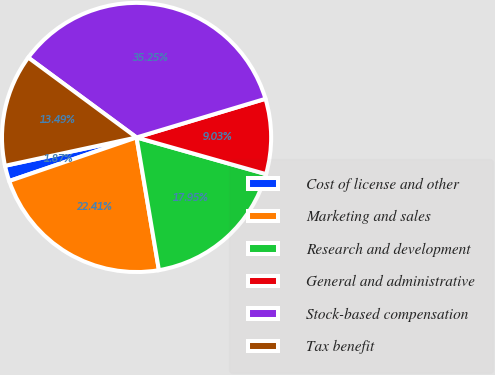<chart> <loc_0><loc_0><loc_500><loc_500><pie_chart><fcel>Cost of license and other<fcel>Marketing and sales<fcel>Research and development<fcel>General and administrative<fcel>Stock-based compensation<fcel>Tax benefit<nl><fcel>1.87%<fcel>22.41%<fcel>17.95%<fcel>9.03%<fcel>35.25%<fcel>13.49%<nl></chart> 